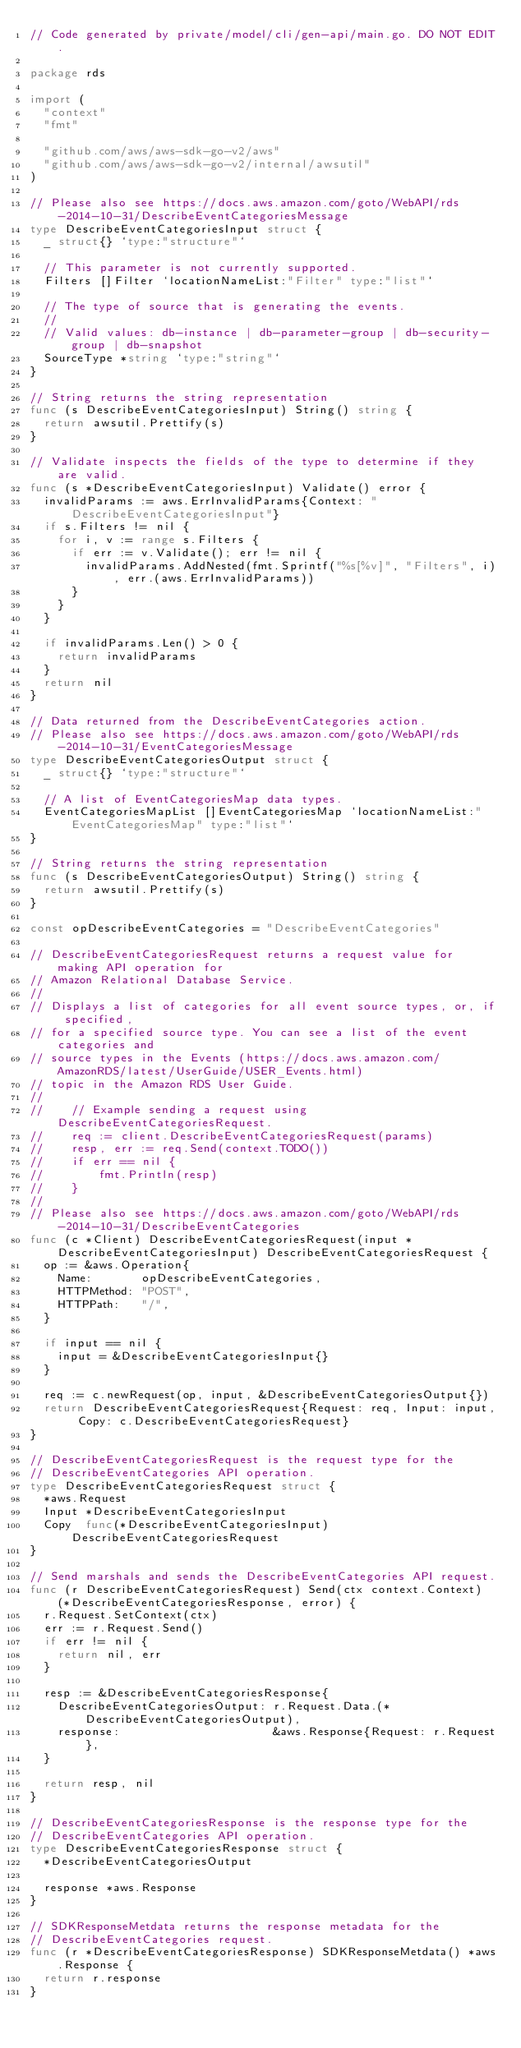<code> <loc_0><loc_0><loc_500><loc_500><_Go_>// Code generated by private/model/cli/gen-api/main.go. DO NOT EDIT.

package rds

import (
	"context"
	"fmt"

	"github.com/aws/aws-sdk-go-v2/aws"
	"github.com/aws/aws-sdk-go-v2/internal/awsutil"
)

// Please also see https://docs.aws.amazon.com/goto/WebAPI/rds-2014-10-31/DescribeEventCategoriesMessage
type DescribeEventCategoriesInput struct {
	_ struct{} `type:"structure"`

	// This parameter is not currently supported.
	Filters []Filter `locationNameList:"Filter" type:"list"`

	// The type of source that is generating the events.
	//
	// Valid values: db-instance | db-parameter-group | db-security-group | db-snapshot
	SourceType *string `type:"string"`
}

// String returns the string representation
func (s DescribeEventCategoriesInput) String() string {
	return awsutil.Prettify(s)
}

// Validate inspects the fields of the type to determine if they are valid.
func (s *DescribeEventCategoriesInput) Validate() error {
	invalidParams := aws.ErrInvalidParams{Context: "DescribeEventCategoriesInput"}
	if s.Filters != nil {
		for i, v := range s.Filters {
			if err := v.Validate(); err != nil {
				invalidParams.AddNested(fmt.Sprintf("%s[%v]", "Filters", i), err.(aws.ErrInvalidParams))
			}
		}
	}

	if invalidParams.Len() > 0 {
		return invalidParams
	}
	return nil
}

// Data returned from the DescribeEventCategories action.
// Please also see https://docs.aws.amazon.com/goto/WebAPI/rds-2014-10-31/EventCategoriesMessage
type DescribeEventCategoriesOutput struct {
	_ struct{} `type:"structure"`

	// A list of EventCategoriesMap data types.
	EventCategoriesMapList []EventCategoriesMap `locationNameList:"EventCategoriesMap" type:"list"`
}

// String returns the string representation
func (s DescribeEventCategoriesOutput) String() string {
	return awsutil.Prettify(s)
}

const opDescribeEventCategories = "DescribeEventCategories"

// DescribeEventCategoriesRequest returns a request value for making API operation for
// Amazon Relational Database Service.
//
// Displays a list of categories for all event source types, or, if specified,
// for a specified source type. You can see a list of the event categories and
// source types in the Events (https://docs.aws.amazon.com/AmazonRDS/latest/UserGuide/USER_Events.html)
// topic in the Amazon RDS User Guide.
//
//    // Example sending a request using DescribeEventCategoriesRequest.
//    req := client.DescribeEventCategoriesRequest(params)
//    resp, err := req.Send(context.TODO())
//    if err == nil {
//        fmt.Println(resp)
//    }
//
// Please also see https://docs.aws.amazon.com/goto/WebAPI/rds-2014-10-31/DescribeEventCategories
func (c *Client) DescribeEventCategoriesRequest(input *DescribeEventCategoriesInput) DescribeEventCategoriesRequest {
	op := &aws.Operation{
		Name:       opDescribeEventCategories,
		HTTPMethod: "POST",
		HTTPPath:   "/",
	}

	if input == nil {
		input = &DescribeEventCategoriesInput{}
	}

	req := c.newRequest(op, input, &DescribeEventCategoriesOutput{})
	return DescribeEventCategoriesRequest{Request: req, Input: input, Copy: c.DescribeEventCategoriesRequest}
}

// DescribeEventCategoriesRequest is the request type for the
// DescribeEventCategories API operation.
type DescribeEventCategoriesRequest struct {
	*aws.Request
	Input *DescribeEventCategoriesInput
	Copy  func(*DescribeEventCategoriesInput) DescribeEventCategoriesRequest
}

// Send marshals and sends the DescribeEventCategories API request.
func (r DescribeEventCategoriesRequest) Send(ctx context.Context) (*DescribeEventCategoriesResponse, error) {
	r.Request.SetContext(ctx)
	err := r.Request.Send()
	if err != nil {
		return nil, err
	}

	resp := &DescribeEventCategoriesResponse{
		DescribeEventCategoriesOutput: r.Request.Data.(*DescribeEventCategoriesOutput),
		response:                      &aws.Response{Request: r.Request},
	}

	return resp, nil
}

// DescribeEventCategoriesResponse is the response type for the
// DescribeEventCategories API operation.
type DescribeEventCategoriesResponse struct {
	*DescribeEventCategoriesOutput

	response *aws.Response
}

// SDKResponseMetdata returns the response metadata for the
// DescribeEventCategories request.
func (r *DescribeEventCategoriesResponse) SDKResponseMetdata() *aws.Response {
	return r.response
}
</code> 